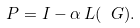<formula> <loc_0><loc_0><loc_500><loc_500>P = I - \alpha \, L ( \ G ) .</formula> 